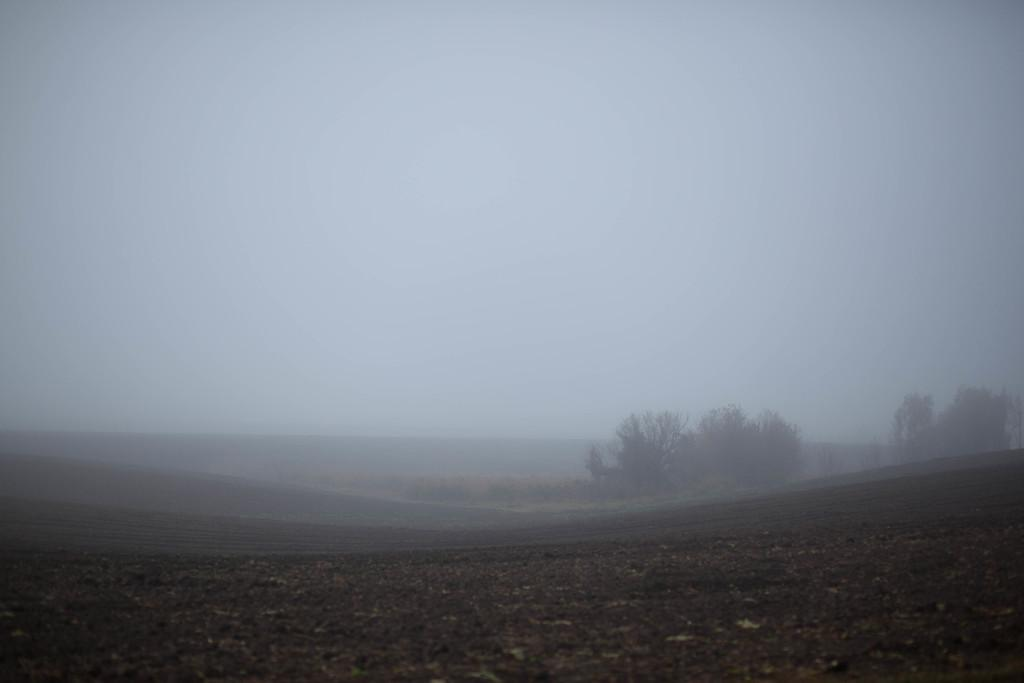What can be seen under the trees in the image? The ground is visible in the image. What type of vegetation is present in the image? There are trees in the image. What atmospheric condition is present in the image? There is fog in the image. What is visible in the distance in the image? The sky is visible in the background of the image. What grade does the tree on the left receive in the image? There is no indication of a grade or evaluation for the tree in the image. What fictional characters can be seen interacting with the fog in the image? There are no fictional characters present in the image; it is a natural scene with trees, ground, fog, and sky. 